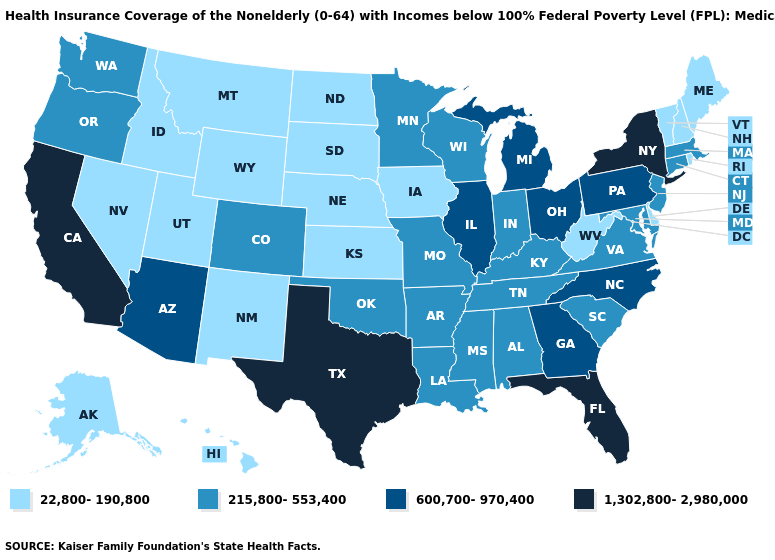What is the highest value in states that border Alabama?
Concise answer only. 1,302,800-2,980,000. What is the value of Arkansas?
Give a very brief answer. 215,800-553,400. Which states have the lowest value in the West?
Concise answer only. Alaska, Hawaii, Idaho, Montana, Nevada, New Mexico, Utah, Wyoming. What is the lowest value in the USA?
Give a very brief answer. 22,800-190,800. Name the states that have a value in the range 600,700-970,400?
Short answer required. Arizona, Georgia, Illinois, Michigan, North Carolina, Ohio, Pennsylvania. Name the states that have a value in the range 600,700-970,400?
Answer briefly. Arizona, Georgia, Illinois, Michigan, North Carolina, Ohio, Pennsylvania. What is the value of Mississippi?
Give a very brief answer. 215,800-553,400. What is the lowest value in the USA?
Concise answer only. 22,800-190,800. Is the legend a continuous bar?
Keep it brief. No. What is the value of Vermont?
Keep it brief. 22,800-190,800. Among the states that border South Dakota , which have the lowest value?
Answer briefly. Iowa, Montana, Nebraska, North Dakota, Wyoming. What is the value of Kentucky?
Keep it brief. 215,800-553,400. Among the states that border Colorado , which have the lowest value?
Keep it brief. Kansas, Nebraska, New Mexico, Utah, Wyoming. How many symbols are there in the legend?
Be succinct. 4. Does the map have missing data?
Concise answer only. No. 